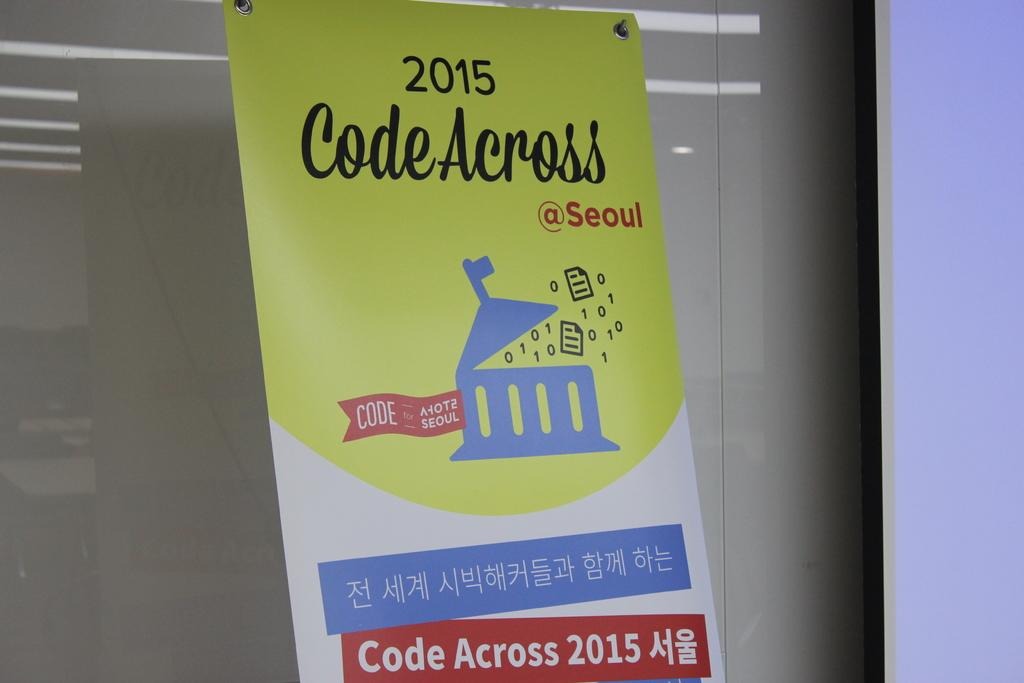Provide a one-sentence caption for the provided image. Code across 2015 with chinese language at the bottom. 